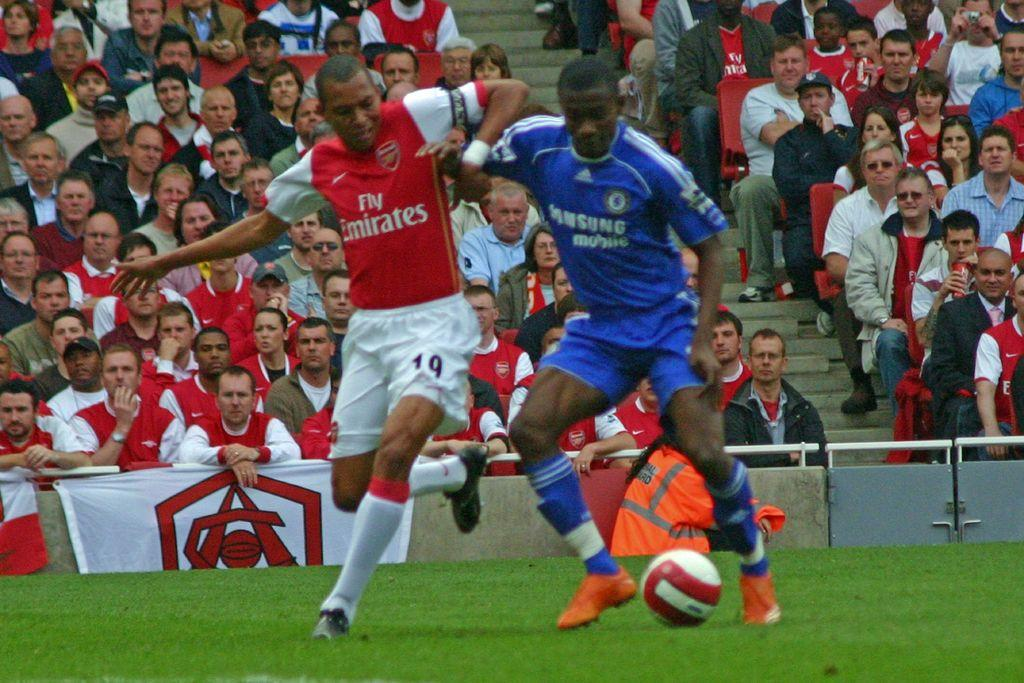<image>
Summarize the visual content of the image. two men in Fly Emirates and Samsung jerseys fight over a soccer ball 